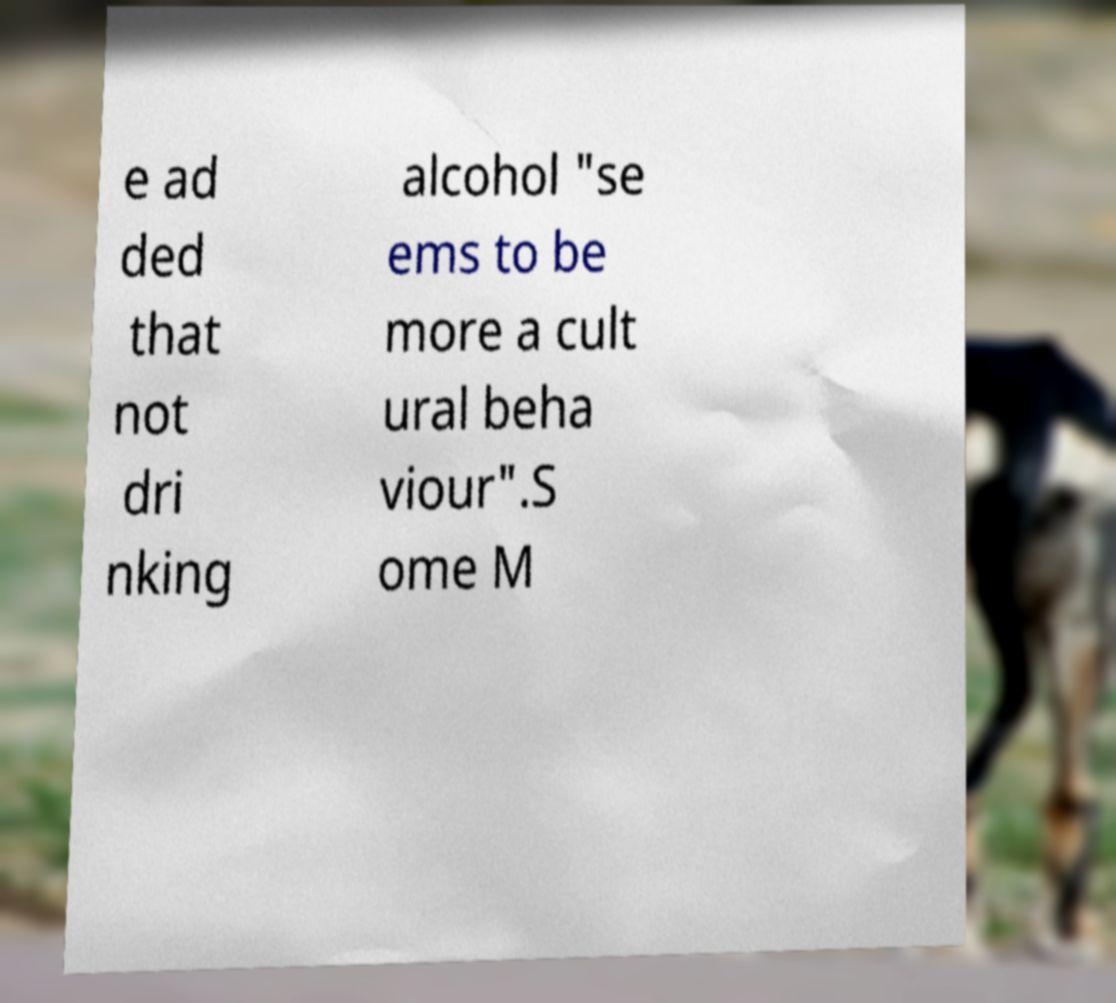What messages or text are displayed in this image? I need them in a readable, typed format. e ad ded that not dri nking alcohol "se ems to be more a cult ural beha viour".S ome M 